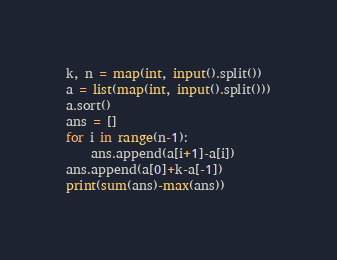Convert code to text. <code><loc_0><loc_0><loc_500><loc_500><_Python_>k, n = map(int, input().split())
a = list(map(int, input().split()))
a.sort()
ans = []
for i in range(n-1):
    ans.append(a[i+1]-a[i])
ans.append(a[0]+k-a[-1])
print(sum(ans)-max(ans))</code> 